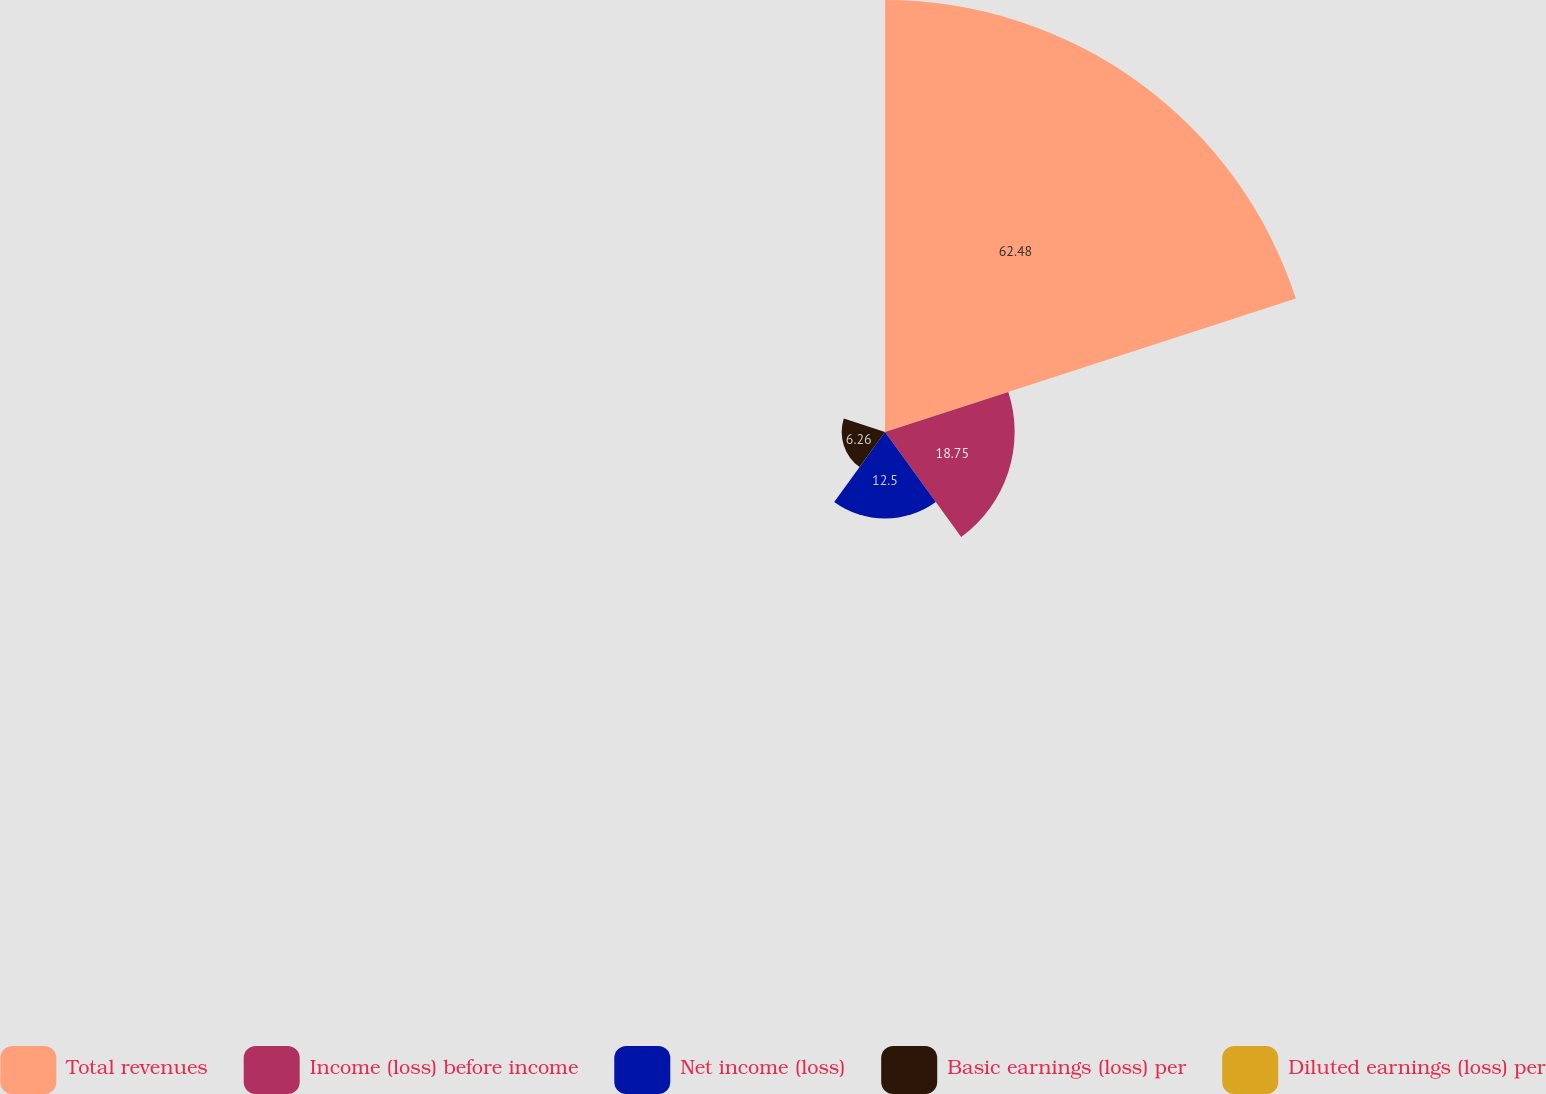<chart> <loc_0><loc_0><loc_500><loc_500><pie_chart><fcel>Total revenues<fcel>Income (loss) before income<fcel>Net income (loss)<fcel>Basic earnings (loss) per<fcel>Diluted earnings (loss) per<nl><fcel>62.48%<fcel>18.75%<fcel>12.5%<fcel>6.26%<fcel>0.01%<nl></chart> 